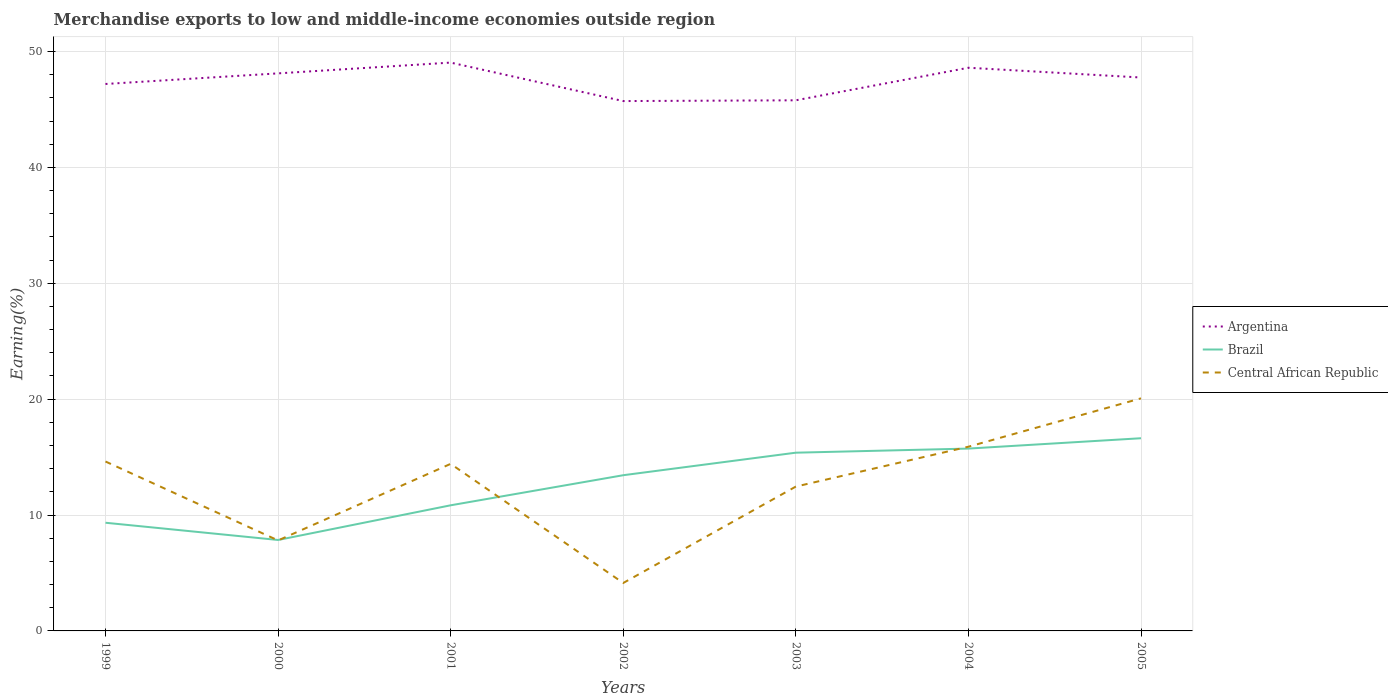Does the line corresponding to Central African Republic intersect with the line corresponding to Argentina?
Your answer should be compact. No. Is the number of lines equal to the number of legend labels?
Your response must be concise. Yes. Across all years, what is the maximum percentage of amount earned from merchandise exports in Brazil?
Offer a very short reply. 7.85. In which year was the percentage of amount earned from merchandise exports in Brazil maximum?
Provide a short and direct response. 2000. What is the total percentage of amount earned from merchandise exports in Argentina in the graph?
Provide a short and direct response. 0.36. What is the difference between the highest and the second highest percentage of amount earned from merchandise exports in Central African Republic?
Keep it short and to the point. 15.93. How many lines are there?
Your answer should be very brief. 3. Where does the legend appear in the graph?
Offer a very short reply. Center right. How many legend labels are there?
Offer a very short reply. 3. How are the legend labels stacked?
Give a very brief answer. Vertical. What is the title of the graph?
Provide a short and direct response. Merchandise exports to low and middle-income economies outside region. Does "Middle East & North Africa (all income levels)" appear as one of the legend labels in the graph?
Offer a very short reply. No. What is the label or title of the X-axis?
Make the answer very short. Years. What is the label or title of the Y-axis?
Offer a terse response. Earning(%). What is the Earning(%) in Argentina in 1999?
Keep it short and to the point. 47.2. What is the Earning(%) of Brazil in 1999?
Offer a very short reply. 9.33. What is the Earning(%) in Central African Republic in 1999?
Your answer should be compact. 14.62. What is the Earning(%) of Argentina in 2000?
Offer a very short reply. 48.11. What is the Earning(%) of Brazil in 2000?
Keep it short and to the point. 7.85. What is the Earning(%) in Central African Republic in 2000?
Provide a succinct answer. 7.81. What is the Earning(%) of Argentina in 2001?
Your answer should be very brief. 49.04. What is the Earning(%) of Brazil in 2001?
Ensure brevity in your answer.  10.84. What is the Earning(%) in Central African Republic in 2001?
Your answer should be very brief. 14.42. What is the Earning(%) of Argentina in 2002?
Provide a succinct answer. 45.72. What is the Earning(%) of Brazil in 2002?
Your response must be concise. 13.44. What is the Earning(%) in Central African Republic in 2002?
Offer a terse response. 4.14. What is the Earning(%) in Argentina in 2003?
Provide a short and direct response. 45.79. What is the Earning(%) of Brazil in 2003?
Give a very brief answer. 15.38. What is the Earning(%) in Central African Republic in 2003?
Make the answer very short. 12.46. What is the Earning(%) in Argentina in 2004?
Your answer should be very brief. 48.6. What is the Earning(%) in Brazil in 2004?
Offer a very short reply. 15.73. What is the Earning(%) of Central African Republic in 2004?
Provide a short and direct response. 15.9. What is the Earning(%) in Argentina in 2005?
Provide a succinct answer. 47.75. What is the Earning(%) of Brazil in 2005?
Your response must be concise. 16.63. What is the Earning(%) of Central African Republic in 2005?
Offer a terse response. 20.07. Across all years, what is the maximum Earning(%) in Argentina?
Give a very brief answer. 49.04. Across all years, what is the maximum Earning(%) of Brazil?
Your response must be concise. 16.63. Across all years, what is the maximum Earning(%) in Central African Republic?
Make the answer very short. 20.07. Across all years, what is the minimum Earning(%) of Argentina?
Give a very brief answer. 45.72. Across all years, what is the minimum Earning(%) in Brazil?
Your response must be concise. 7.85. Across all years, what is the minimum Earning(%) of Central African Republic?
Provide a short and direct response. 4.14. What is the total Earning(%) of Argentina in the graph?
Keep it short and to the point. 332.21. What is the total Earning(%) in Brazil in the graph?
Make the answer very short. 89.2. What is the total Earning(%) in Central African Republic in the graph?
Your answer should be compact. 89.4. What is the difference between the Earning(%) in Argentina in 1999 and that in 2000?
Offer a very short reply. -0.91. What is the difference between the Earning(%) in Brazil in 1999 and that in 2000?
Offer a very short reply. 1.49. What is the difference between the Earning(%) in Central African Republic in 1999 and that in 2000?
Your answer should be compact. 6.81. What is the difference between the Earning(%) in Argentina in 1999 and that in 2001?
Keep it short and to the point. -1.85. What is the difference between the Earning(%) of Brazil in 1999 and that in 2001?
Your answer should be very brief. -1.51. What is the difference between the Earning(%) in Central African Republic in 1999 and that in 2001?
Make the answer very short. 0.2. What is the difference between the Earning(%) of Argentina in 1999 and that in 2002?
Offer a very short reply. 1.47. What is the difference between the Earning(%) of Brazil in 1999 and that in 2002?
Keep it short and to the point. -4.1. What is the difference between the Earning(%) of Central African Republic in 1999 and that in 2002?
Offer a terse response. 10.48. What is the difference between the Earning(%) of Argentina in 1999 and that in 2003?
Keep it short and to the point. 1.41. What is the difference between the Earning(%) in Brazil in 1999 and that in 2003?
Your answer should be very brief. -6.05. What is the difference between the Earning(%) in Central African Republic in 1999 and that in 2003?
Ensure brevity in your answer.  2.16. What is the difference between the Earning(%) in Argentina in 1999 and that in 2004?
Offer a terse response. -1.4. What is the difference between the Earning(%) in Brazil in 1999 and that in 2004?
Provide a short and direct response. -6.4. What is the difference between the Earning(%) of Central African Republic in 1999 and that in 2004?
Your answer should be very brief. -1.28. What is the difference between the Earning(%) of Argentina in 1999 and that in 2005?
Your answer should be compact. -0.56. What is the difference between the Earning(%) of Brazil in 1999 and that in 2005?
Keep it short and to the point. -7.29. What is the difference between the Earning(%) of Central African Republic in 1999 and that in 2005?
Provide a succinct answer. -5.45. What is the difference between the Earning(%) of Argentina in 2000 and that in 2001?
Your answer should be very brief. -0.93. What is the difference between the Earning(%) of Brazil in 2000 and that in 2001?
Offer a very short reply. -2.99. What is the difference between the Earning(%) of Central African Republic in 2000 and that in 2001?
Ensure brevity in your answer.  -6.61. What is the difference between the Earning(%) in Argentina in 2000 and that in 2002?
Make the answer very short. 2.39. What is the difference between the Earning(%) of Brazil in 2000 and that in 2002?
Provide a succinct answer. -5.59. What is the difference between the Earning(%) of Central African Republic in 2000 and that in 2002?
Make the answer very short. 3.67. What is the difference between the Earning(%) in Argentina in 2000 and that in 2003?
Offer a very short reply. 2.32. What is the difference between the Earning(%) in Brazil in 2000 and that in 2003?
Your answer should be very brief. -7.53. What is the difference between the Earning(%) of Central African Republic in 2000 and that in 2003?
Provide a succinct answer. -4.65. What is the difference between the Earning(%) in Argentina in 2000 and that in 2004?
Provide a short and direct response. -0.49. What is the difference between the Earning(%) of Brazil in 2000 and that in 2004?
Your answer should be compact. -7.89. What is the difference between the Earning(%) of Central African Republic in 2000 and that in 2004?
Provide a succinct answer. -8.09. What is the difference between the Earning(%) of Argentina in 2000 and that in 2005?
Your response must be concise. 0.36. What is the difference between the Earning(%) in Brazil in 2000 and that in 2005?
Provide a short and direct response. -8.78. What is the difference between the Earning(%) in Central African Republic in 2000 and that in 2005?
Make the answer very short. -12.26. What is the difference between the Earning(%) in Argentina in 2001 and that in 2002?
Provide a short and direct response. 3.32. What is the difference between the Earning(%) of Brazil in 2001 and that in 2002?
Keep it short and to the point. -2.6. What is the difference between the Earning(%) in Central African Republic in 2001 and that in 2002?
Your answer should be compact. 10.28. What is the difference between the Earning(%) of Argentina in 2001 and that in 2003?
Give a very brief answer. 3.25. What is the difference between the Earning(%) in Brazil in 2001 and that in 2003?
Provide a succinct answer. -4.54. What is the difference between the Earning(%) in Central African Republic in 2001 and that in 2003?
Ensure brevity in your answer.  1.96. What is the difference between the Earning(%) in Argentina in 2001 and that in 2004?
Your answer should be very brief. 0.44. What is the difference between the Earning(%) of Brazil in 2001 and that in 2004?
Provide a short and direct response. -4.89. What is the difference between the Earning(%) in Central African Republic in 2001 and that in 2004?
Provide a short and direct response. -1.48. What is the difference between the Earning(%) of Argentina in 2001 and that in 2005?
Your answer should be very brief. 1.29. What is the difference between the Earning(%) in Brazil in 2001 and that in 2005?
Make the answer very short. -5.79. What is the difference between the Earning(%) of Central African Republic in 2001 and that in 2005?
Make the answer very short. -5.65. What is the difference between the Earning(%) of Argentina in 2002 and that in 2003?
Provide a succinct answer. -0.07. What is the difference between the Earning(%) in Brazil in 2002 and that in 2003?
Your answer should be very brief. -1.94. What is the difference between the Earning(%) in Central African Republic in 2002 and that in 2003?
Your answer should be very brief. -8.32. What is the difference between the Earning(%) of Argentina in 2002 and that in 2004?
Provide a short and direct response. -2.88. What is the difference between the Earning(%) in Brazil in 2002 and that in 2004?
Give a very brief answer. -2.3. What is the difference between the Earning(%) in Central African Republic in 2002 and that in 2004?
Offer a very short reply. -11.76. What is the difference between the Earning(%) in Argentina in 2002 and that in 2005?
Keep it short and to the point. -2.03. What is the difference between the Earning(%) in Brazil in 2002 and that in 2005?
Keep it short and to the point. -3.19. What is the difference between the Earning(%) of Central African Republic in 2002 and that in 2005?
Ensure brevity in your answer.  -15.93. What is the difference between the Earning(%) in Argentina in 2003 and that in 2004?
Provide a short and direct response. -2.81. What is the difference between the Earning(%) in Brazil in 2003 and that in 2004?
Your answer should be very brief. -0.35. What is the difference between the Earning(%) in Central African Republic in 2003 and that in 2004?
Offer a very short reply. -3.44. What is the difference between the Earning(%) of Argentina in 2003 and that in 2005?
Provide a succinct answer. -1.97. What is the difference between the Earning(%) of Brazil in 2003 and that in 2005?
Provide a succinct answer. -1.25. What is the difference between the Earning(%) of Central African Republic in 2003 and that in 2005?
Your response must be concise. -7.61. What is the difference between the Earning(%) of Argentina in 2004 and that in 2005?
Provide a short and direct response. 0.84. What is the difference between the Earning(%) of Brazil in 2004 and that in 2005?
Offer a very short reply. -0.89. What is the difference between the Earning(%) of Central African Republic in 2004 and that in 2005?
Make the answer very short. -4.17. What is the difference between the Earning(%) of Argentina in 1999 and the Earning(%) of Brazil in 2000?
Keep it short and to the point. 39.35. What is the difference between the Earning(%) of Argentina in 1999 and the Earning(%) of Central African Republic in 2000?
Give a very brief answer. 39.39. What is the difference between the Earning(%) of Brazil in 1999 and the Earning(%) of Central African Republic in 2000?
Give a very brief answer. 1.53. What is the difference between the Earning(%) in Argentina in 1999 and the Earning(%) in Brazil in 2001?
Your answer should be very brief. 36.36. What is the difference between the Earning(%) in Argentina in 1999 and the Earning(%) in Central African Republic in 2001?
Keep it short and to the point. 32.78. What is the difference between the Earning(%) in Brazil in 1999 and the Earning(%) in Central African Republic in 2001?
Give a very brief answer. -5.08. What is the difference between the Earning(%) in Argentina in 1999 and the Earning(%) in Brazil in 2002?
Offer a terse response. 33.76. What is the difference between the Earning(%) of Argentina in 1999 and the Earning(%) of Central African Republic in 2002?
Your answer should be very brief. 43.06. What is the difference between the Earning(%) of Brazil in 1999 and the Earning(%) of Central African Republic in 2002?
Provide a succinct answer. 5.2. What is the difference between the Earning(%) of Argentina in 1999 and the Earning(%) of Brazil in 2003?
Provide a short and direct response. 31.82. What is the difference between the Earning(%) in Argentina in 1999 and the Earning(%) in Central African Republic in 2003?
Your answer should be compact. 34.74. What is the difference between the Earning(%) in Brazil in 1999 and the Earning(%) in Central African Republic in 2003?
Ensure brevity in your answer.  -3.12. What is the difference between the Earning(%) in Argentina in 1999 and the Earning(%) in Brazil in 2004?
Your answer should be compact. 31.46. What is the difference between the Earning(%) in Argentina in 1999 and the Earning(%) in Central African Republic in 2004?
Provide a succinct answer. 31.3. What is the difference between the Earning(%) of Brazil in 1999 and the Earning(%) of Central African Republic in 2004?
Keep it short and to the point. -6.56. What is the difference between the Earning(%) in Argentina in 1999 and the Earning(%) in Brazil in 2005?
Your answer should be compact. 30.57. What is the difference between the Earning(%) of Argentina in 1999 and the Earning(%) of Central African Republic in 2005?
Offer a terse response. 27.13. What is the difference between the Earning(%) in Brazil in 1999 and the Earning(%) in Central African Republic in 2005?
Ensure brevity in your answer.  -10.73. What is the difference between the Earning(%) in Argentina in 2000 and the Earning(%) in Brazil in 2001?
Keep it short and to the point. 37.27. What is the difference between the Earning(%) of Argentina in 2000 and the Earning(%) of Central African Republic in 2001?
Keep it short and to the point. 33.69. What is the difference between the Earning(%) in Brazil in 2000 and the Earning(%) in Central African Republic in 2001?
Your answer should be very brief. -6.57. What is the difference between the Earning(%) in Argentina in 2000 and the Earning(%) in Brazil in 2002?
Provide a short and direct response. 34.68. What is the difference between the Earning(%) of Argentina in 2000 and the Earning(%) of Central African Republic in 2002?
Make the answer very short. 43.97. What is the difference between the Earning(%) in Brazil in 2000 and the Earning(%) in Central African Republic in 2002?
Make the answer very short. 3.71. What is the difference between the Earning(%) in Argentina in 2000 and the Earning(%) in Brazil in 2003?
Provide a short and direct response. 32.73. What is the difference between the Earning(%) in Argentina in 2000 and the Earning(%) in Central African Republic in 2003?
Your answer should be compact. 35.66. What is the difference between the Earning(%) in Brazil in 2000 and the Earning(%) in Central African Republic in 2003?
Offer a terse response. -4.61. What is the difference between the Earning(%) of Argentina in 2000 and the Earning(%) of Brazil in 2004?
Give a very brief answer. 32.38. What is the difference between the Earning(%) in Argentina in 2000 and the Earning(%) in Central African Republic in 2004?
Your answer should be compact. 32.22. What is the difference between the Earning(%) in Brazil in 2000 and the Earning(%) in Central African Republic in 2004?
Keep it short and to the point. -8.05. What is the difference between the Earning(%) in Argentina in 2000 and the Earning(%) in Brazil in 2005?
Offer a very short reply. 31.48. What is the difference between the Earning(%) in Argentina in 2000 and the Earning(%) in Central African Republic in 2005?
Offer a very short reply. 28.04. What is the difference between the Earning(%) in Brazil in 2000 and the Earning(%) in Central African Republic in 2005?
Keep it short and to the point. -12.22. What is the difference between the Earning(%) in Argentina in 2001 and the Earning(%) in Brazil in 2002?
Offer a terse response. 35.61. What is the difference between the Earning(%) of Argentina in 2001 and the Earning(%) of Central African Republic in 2002?
Keep it short and to the point. 44.9. What is the difference between the Earning(%) of Brazil in 2001 and the Earning(%) of Central African Republic in 2002?
Your response must be concise. 6.7. What is the difference between the Earning(%) in Argentina in 2001 and the Earning(%) in Brazil in 2003?
Keep it short and to the point. 33.66. What is the difference between the Earning(%) of Argentina in 2001 and the Earning(%) of Central African Republic in 2003?
Your answer should be compact. 36.59. What is the difference between the Earning(%) of Brazil in 2001 and the Earning(%) of Central African Republic in 2003?
Ensure brevity in your answer.  -1.62. What is the difference between the Earning(%) in Argentina in 2001 and the Earning(%) in Brazil in 2004?
Your response must be concise. 33.31. What is the difference between the Earning(%) of Argentina in 2001 and the Earning(%) of Central African Republic in 2004?
Offer a very short reply. 33.15. What is the difference between the Earning(%) of Brazil in 2001 and the Earning(%) of Central African Republic in 2004?
Ensure brevity in your answer.  -5.06. What is the difference between the Earning(%) in Argentina in 2001 and the Earning(%) in Brazil in 2005?
Provide a succinct answer. 32.41. What is the difference between the Earning(%) of Argentina in 2001 and the Earning(%) of Central African Republic in 2005?
Make the answer very short. 28.97. What is the difference between the Earning(%) of Brazil in 2001 and the Earning(%) of Central African Republic in 2005?
Make the answer very short. -9.23. What is the difference between the Earning(%) of Argentina in 2002 and the Earning(%) of Brazil in 2003?
Your answer should be compact. 30.34. What is the difference between the Earning(%) in Argentina in 2002 and the Earning(%) in Central African Republic in 2003?
Ensure brevity in your answer.  33.27. What is the difference between the Earning(%) in Brazil in 2002 and the Earning(%) in Central African Republic in 2003?
Give a very brief answer. 0.98. What is the difference between the Earning(%) of Argentina in 2002 and the Earning(%) of Brazil in 2004?
Give a very brief answer. 29.99. What is the difference between the Earning(%) of Argentina in 2002 and the Earning(%) of Central African Republic in 2004?
Ensure brevity in your answer.  29.83. What is the difference between the Earning(%) in Brazil in 2002 and the Earning(%) in Central African Republic in 2004?
Provide a succinct answer. -2.46. What is the difference between the Earning(%) in Argentina in 2002 and the Earning(%) in Brazil in 2005?
Your response must be concise. 29.09. What is the difference between the Earning(%) in Argentina in 2002 and the Earning(%) in Central African Republic in 2005?
Your answer should be compact. 25.65. What is the difference between the Earning(%) in Brazil in 2002 and the Earning(%) in Central African Republic in 2005?
Your answer should be compact. -6.63. What is the difference between the Earning(%) of Argentina in 2003 and the Earning(%) of Brazil in 2004?
Provide a succinct answer. 30.05. What is the difference between the Earning(%) in Argentina in 2003 and the Earning(%) in Central African Republic in 2004?
Offer a terse response. 29.89. What is the difference between the Earning(%) of Brazil in 2003 and the Earning(%) of Central African Republic in 2004?
Your answer should be very brief. -0.52. What is the difference between the Earning(%) in Argentina in 2003 and the Earning(%) in Brazil in 2005?
Offer a terse response. 29.16. What is the difference between the Earning(%) of Argentina in 2003 and the Earning(%) of Central African Republic in 2005?
Provide a short and direct response. 25.72. What is the difference between the Earning(%) in Brazil in 2003 and the Earning(%) in Central African Republic in 2005?
Offer a very short reply. -4.69. What is the difference between the Earning(%) in Argentina in 2004 and the Earning(%) in Brazil in 2005?
Make the answer very short. 31.97. What is the difference between the Earning(%) in Argentina in 2004 and the Earning(%) in Central African Republic in 2005?
Ensure brevity in your answer.  28.53. What is the difference between the Earning(%) in Brazil in 2004 and the Earning(%) in Central African Republic in 2005?
Your response must be concise. -4.34. What is the average Earning(%) in Argentina per year?
Your answer should be very brief. 47.46. What is the average Earning(%) of Brazil per year?
Provide a short and direct response. 12.74. What is the average Earning(%) of Central African Republic per year?
Make the answer very short. 12.77. In the year 1999, what is the difference between the Earning(%) of Argentina and Earning(%) of Brazil?
Offer a terse response. 37.86. In the year 1999, what is the difference between the Earning(%) of Argentina and Earning(%) of Central African Republic?
Give a very brief answer. 32.58. In the year 1999, what is the difference between the Earning(%) in Brazil and Earning(%) in Central African Republic?
Your response must be concise. -5.28. In the year 2000, what is the difference between the Earning(%) of Argentina and Earning(%) of Brazil?
Provide a succinct answer. 40.26. In the year 2000, what is the difference between the Earning(%) of Argentina and Earning(%) of Central African Republic?
Provide a succinct answer. 40.3. In the year 2000, what is the difference between the Earning(%) of Brazil and Earning(%) of Central African Republic?
Give a very brief answer. 0.04. In the year 2001, what is the difference between the Earning(%) of Argentina and Earning(%) of Brazil?
Provide a succinct answer. 38.2. In the year 2001, what is the difference between the Earning(%) in Argentina and Earning(%) in Central African Republic?
Give a very brief answer. 34.63. In the year 2001, what is the difference between the Earning(%) of Brazil and Earning(%) of Central African Republic?
Your response must be concise. -3.58. In the year 2002, what is the difference between the Earning(%) in Argentina and Earning(%) in Brazil?
Give a very brief answer. 32.29. In the year 2002, what is the difference between the Earning(%) in Argentina and Earning(%) in Central African Republic?
Your answer should be very brief. 41.58. In the year 2002, what is the difference between the Earning(%) in Brazil and Earning(%) in Central African Republic?
Your response must be concise. 9.3. In the year 2003, what is the difference between the Earning(%) of Argentina and Earning(%) of Brazil?
Provide a succinct answer. 30.41. In the year 2003, what is the difference between the Earning(%) in Argentina and Earning(%) in Central African Republic?
Ensure brevity in your answer.  33.33. In the year 2003, what is the difference between the Earning(%) in Brazil and Earning(%) in Central African Republic?
Keep it short and to the point. 2.92. In the year 2004, what is the difference between the Earning(%) in Argentina and Earning(%) in Brazil?
Provide a short and direct response. 32.86. In the year 2004, what is the difference between the Earning(%) of Argentina and Earning(%) of Central African Republic?
Offer a very short reply. 32.7. In the year 2004, what is the difference between the Earning(%) in Brazil and Earning(%) in Central African Republic?
Provide a succinct answer. -0.16. In the year 2005, what is the difference between the Earning(%) in Argentina and Earning(%) in Brazil?
Provide a short and direct response. 31.13. In the year 2005, what is the difference between the Earning(%) of Argentina and Earning(%) of Central African Republic?
Make the answer very short. 27.68. In the year 2005, what is the difference between the Earning(%) in Brazil and Earning(%) in Central African Republic?
Give a very brief answer. -3.44. What is the ratio of the Earning(%) in Argentina in 1999 to that in 2000?
Ensure brevity in your answer.  0.98. What is the ratio of the Earning(%) of Brazil in 1999 to that in 2000?
Your answer should be compact. 1.19. What is the ratio of the Earning(%) of Central African Republic in 1999 to that in 2000?
Make the answer very short. 1.87. What is the ratio of the Earning(%) of Argentina in 1999 to that in 2001?
Provide a succinct answer. 0.96. What is the ratio of the Earning(%) in Brazil in 1999 to that in 2001?
Your response must be concise. 0.86. What is the ratio of the Earning(%) in Central African Republic in 1999 to that in 2001?
Your answer should be compact. 1.01. What is the ratio of the Earning(%) in Argentina in 1999 to that in 2002?
Keep it short and to the point. 1.03. What is the ratio of the Earning(%) in Brazil in 1999 to that in 2002?
Make the answer very short. 0.69. What is the ratio of the Earning(%) in Central African Republic in 1999 to that in 2002?
Provide a succinct answer. 3.53. What is the ratio of the Earning(%) of Argentina in 1999 to that in 2003?
Offer a terse response. 1.03. What is the ratio of the Earning(%) of Brazil in 1999 to that in 2003?
Your response must be concise. 0.61. What is the ratio of the Earning(%) in Central African Republic in 1999 to that in 2003?
Provide a short and direct response. 1.17. What is the ratio of the Earning(%) of Argentina in 1999 to that in 2004?
Your response must be concise. 0.97. What is the ratio of the Earning(%) of Brazil in 1999 to that in 2004?
Offer a very short reply. 0.59. What is the ratio of the Earning(%) of Central African Republic in 1999 to that in 2004?
Keep it short and to the point. 0.92. What is the ratio of the Earning(%) in Argentina in 1999 to that in 2005?
Give a very brief answer. 0.99. What is the ratio of the Earning(%) of Brazil in 1999 to that in 2005?
Offer a terse response. 0.56. What is the ratio of the Earning(%) of Central African Republic in 1999 to that in 2005?
Offer a very short reply. 0.73. What is the ratio of the Earning(%) of Argentina in 2000 to that in 2001?
Your answer should be compact. 0.98. What is the ratio of the Earning(%) of Brazil in 2000 to that in 2001?
Make the answer very short. 0.72. What is the ratio of the Earning(%) of Central African Republic in 2000 to that in 2001?
Give a very brief answer. 0.54. What is the ratio of the Earning(%) of Argentina in 2000 to that in 2002?
Keep it short and to the point. 1.05. What is the ratio of the Earning(%) in Brazil in 2000 to that in 2002?
Your response must be concise. 0.58. What is the ratio of the Earning(%) in Central African Republic in 2000 to that in 2002?
Give a very brief answer. 1.89. What is the ratio of the Earning(%) of Argentina in 2000 to that in 2003?
Provide a short and direct response. 1.05. What is the ratio of the Earning(%) of Brazil in 2000 to that in 2003?
Your answer should be compact. 0.51. What is the ratio of the Earning(%) of Central African Republic in 2000 to that in 2003?
Provide a short and direct response. 0.63. What is the ratio of the Earning(%) of Brazil in 2000 to that in 2004?
Provide a succinct answer. 0.5. What is the ratio of the Earning(%) in Central African Republic in 2000 to that in 2004?
Make the answer very short. 0.49. What is the ratio of the Earning(%) in Argentina in 2000 to that in 2005?
Keep it short and to the point. 1.01. What is the ratio of the Earning(%) of Brazil in 2000 to that in 2005?
Your answer should be very brief. 0.47. What is the ratio of the Earning(%) in Central African Republic in 2000 to that in 2005?
Ensure brevity in your answer.  0.39. What is the ratio of the Earning(%) in Argentina in 2001 to that in 2002?
Make the answer very short. 1.07. What is the ratio of the Earning(%) in Brazil in 2001 to that in 2002?
Offer a very short reply. 0.81. What is the ratio of the Earning(%) of Central African Republic in 2001 to that in 2002?
Give a very brief answer. 3.48. What is the ratio of the Earning(%) of Argentina in 2001 to that in 2003?
Your answer should be compact. 1.07. What is the ratio of the Earning(%) of Brazil in 2001 to that in 2003?
Give a very brief answer. 0.7. What is the ratio of the Earning(%) of Central African Republic in 2001 to that in 2003?
Provide a short and direct response. 1.16. What is the ratio of the Earning(%) in Argentina in 2001 to that in 2004?
Make the answer very short. 1.01. What is the ratio of the Earning(%) in Brazil in 2001 to that in 2004?
Ensure brevity in your answer.  0.69. What is the ratio of the Earning(%) of Central African Republic in 2001 to that in 2004?
Make the answer very short. 0.91. What is the ratio of the Earning(%) of Argentina in 2001 to that in 2005?
Your answer should be very brief. 1.03. What is the ratio of the Earning(%) in Brazil in 2001 to that in 2005?
Provide a succinct answer. 0.65. What is the ratio of the Earning(%) in Central African Republic in 2001 to that in 2005?
Keep it short and to the point. 0.72. What is the ratio of the Earning(%) in Brazil in 2002 to that in 2003?
Your answer should be very brief. 0.87. What is the ratio of the Earning(%) of Central African Republic in 2002 to that in 2003?
Make the answer very short. 0.33. What is the ratio of the Earning(%) of Argentina in 2002 to that in 2004?
Ensure brevity in your answer.  0.94. What is the ratio of the Earning(%) of Brazil in 2002 to that in 2004?
Give a very brief answer. 0.85. What is the ratio of the Earning(%) of Central African Republic in 2002 to that in 2004?
Offer a terse response. 0.26. What is the ratio of the Earning(%) in Argentina in 2002 to that in 2005?
Give a very brief answer. 0.96. What is the ratio of the Earning(%) in Brazil in 2002 to that in 2005?
Ensure brevity in your answer.  0.81. What is the ratio of the Earning(%) in Central African Republic in 2002 to that in 2005?
Provide a short and direct response. 0.21. What is the ratio of the Earning(%) of Argentina in 2003 to that in 2004?
Your answer should be compact. 0.94. What is the ratio of the Earning(%) of Brazil in 2003 to that in 2004?
Keep it short and to the point. 0.98. What is the ratio of the Earning(%) in Central African Republic in 2003 to that in 2004?
Your answer should be very brief. 0.78. What is the ratio of the Earning(%) of Argentina in 2003 to that in 2005?
Ensure brevity in your answer.  0.96. What is the ratio of the Earning(%) in Brazil in 2003 to that in 2005?
Make the answer very short. 0.93. What is the ratio of the Earning(%) in Central African Republic in 2003 to that in 2005?
Ensure brevity in your answer.  0.62. What is the ratio of the Earning(%) in Argentina in 2004 to that in 2005?
Keep it short and to the point. 1.02. What is the ratio of the Earning(%) of Brazil in 2004 to that in 2005?
Offer a very short reply. 0.95. What is the ratio of the Earning(%) in Central African Republic in 2004 to that in 2005?
Your response must be concise. 0.79. What is the difference between the highest and the second highest Earning(%) in Argentina?
Provide a short and direct response. 0.44. What is the difference between the highest and the second highest Earning(%) of Brazil?
Your response must be concise. 0.89. What is the difference between the highest and the second highest Earning(%) of Central African Republic?
Give a very brief answer. 4.17. What is the difference between the highest and the lowest Earning(%) in Argentina?
Ensure brevity in your answer.  3.32. What is the difference between the highest and the lowest Earning(%) of Brazil?
Your response must be concise. 8.78. What is the difference between the highest and the lowest Earning(%) in Central African Republic?
Provide a short and direct response. 15.93. 